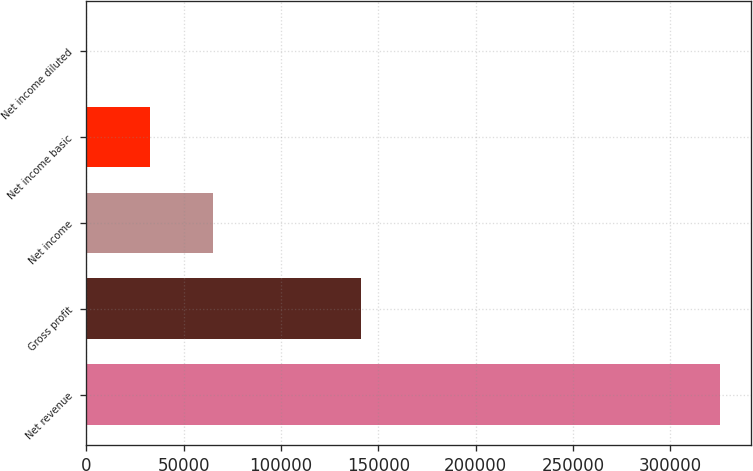<chart> <loc_0><loc_0><loc_500><loc_500><bar_chart><fcel>Net revenue<fcel>Gross profit<fcel>Net income<fcel>Net income basic<fcel>Net income diluted<nl><fcel>325411<fcel>140981<fcel>65082.4<fcel>32541.3<fcel>0.26<nl></chart> 